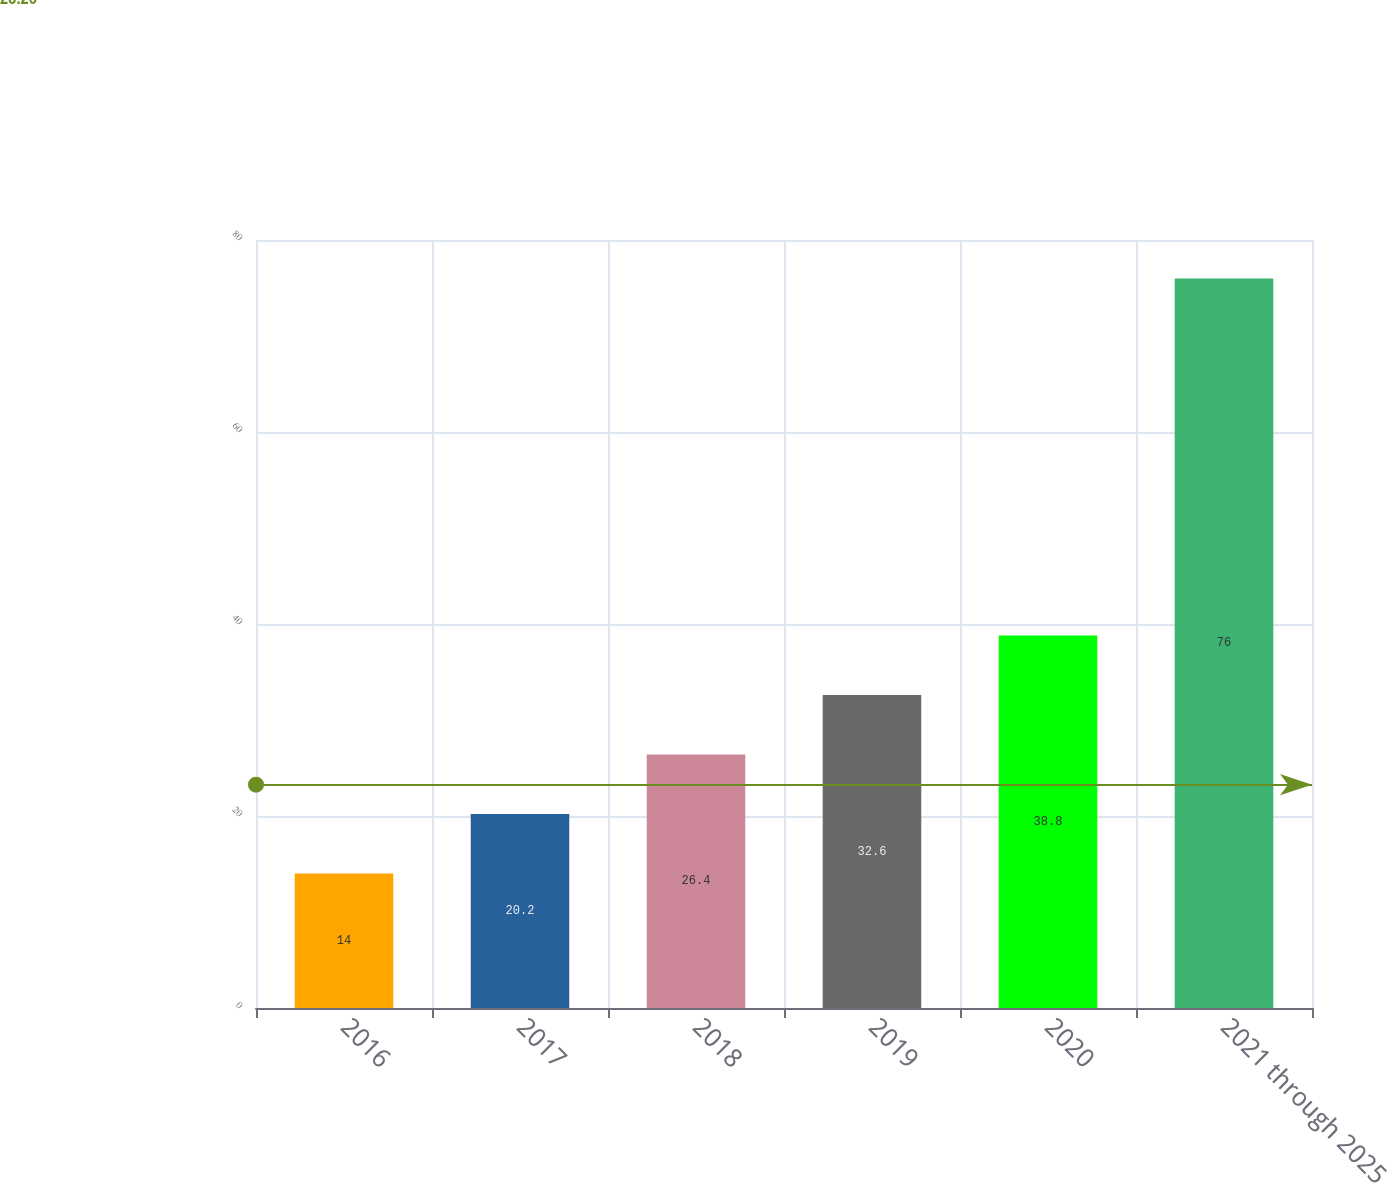Convert chart to OTSL. <chart><loc_0><loc_0><loc_500><loc_500><bar_chart><fcel>2016<fcel>2017<fcel>2018<fcel>2019<fcel>2020<fcel>2021 through 2025<nl><fcel>14<fcel>20.2<fcel>26.4<fcel>32.6<fcel>38.8<fcel>76<nl></chart> 